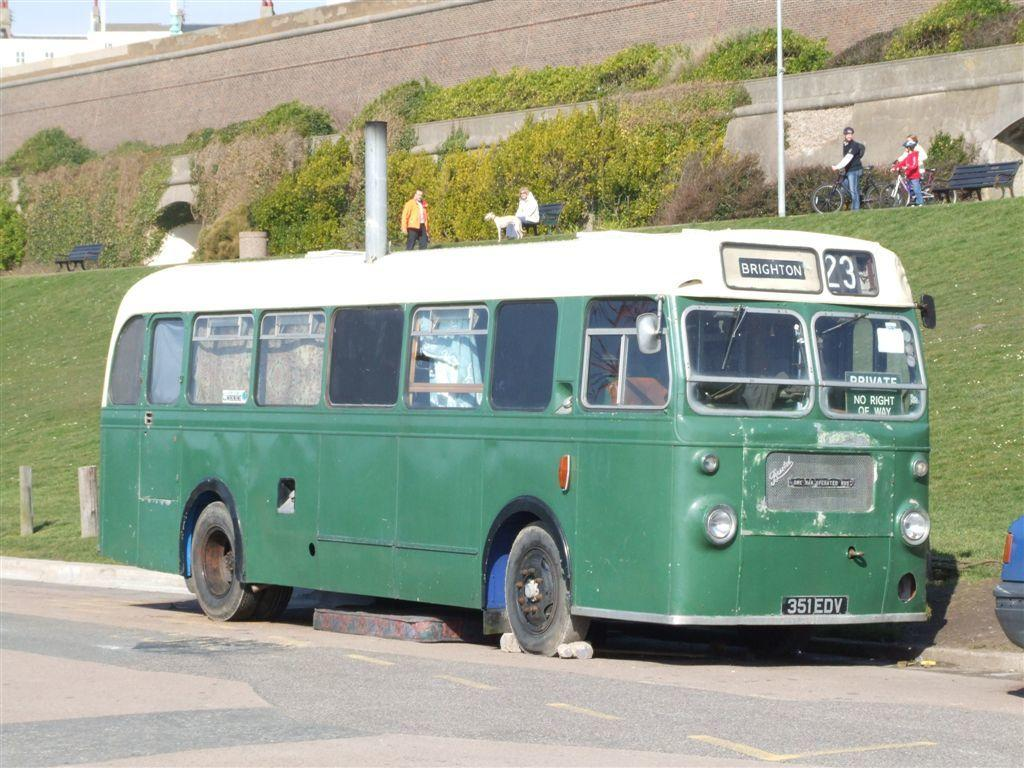<image>
Render a clear and concise summary of the photo. Brighton Bus # 23 with the front plate saying: 351EDV. 